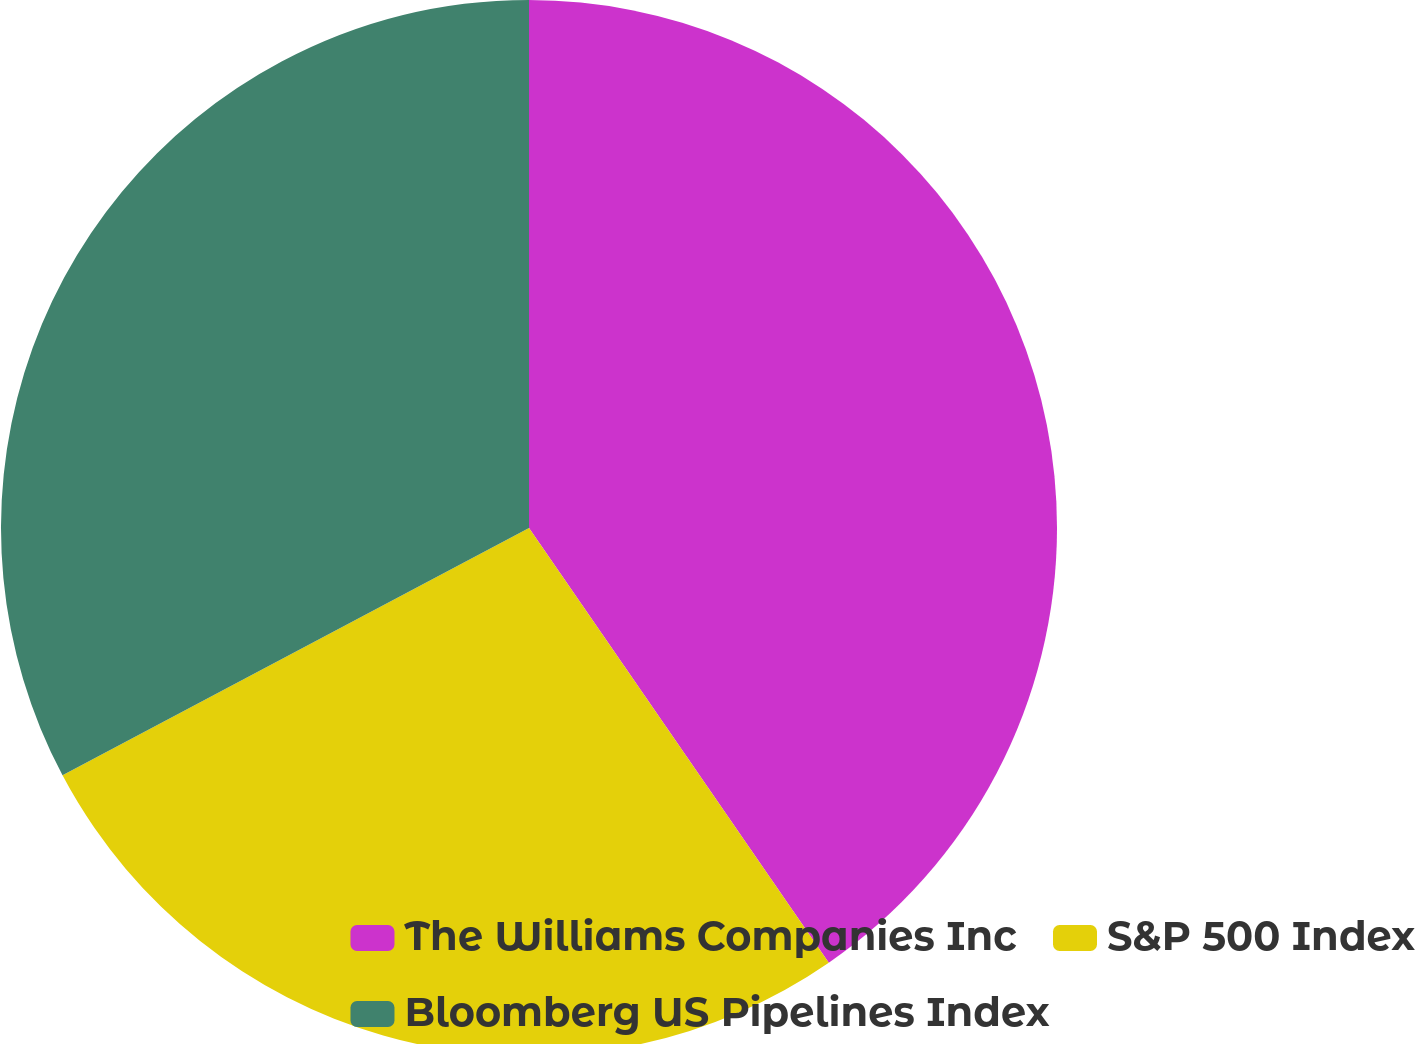Convert chart to OTSL. <chart><loc_0><loc_0><loc_500><loc_500><pie_chart><fcel>The Williams Companies Inc<fcel>S&P 500 Index<fcel>Bloomberg US Pipelines Index<nl><fcel>40.39%<fcel>26.85%<fcel>32.76%<nl></chart> 